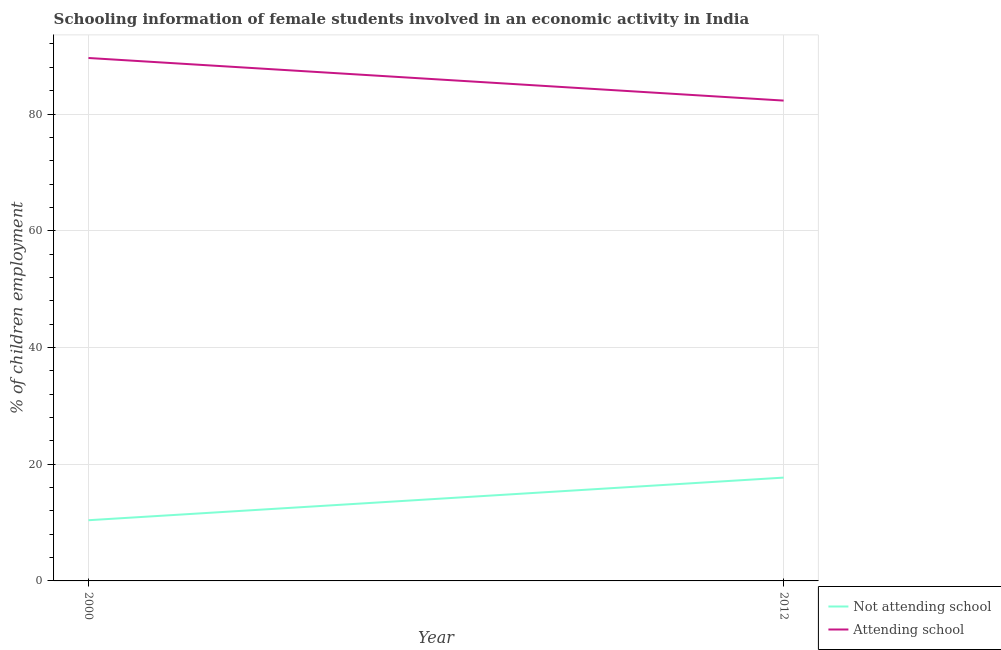What is the percentage of employed females who are not attending school in 2012?
Your answer should be very brief. 17.7. Across all years, what is the maximum percentage of employed females who are not attending school?
Provide a short and direct response. 17.7. In which year was the percentage of employed females who are attending school maximum?
Ensure brevity in your answer.  2000. In which year was the percentage of employed females who are attending school minimum?
Offer a terse response. 2012. What is the total percentage of employed females who are not attending school in the graph?
Offer a terse response. 28.1. What is the difference between the percentage of employed females who are not attending school in 2000 and that in 2012?
Provide a succinct answer. -7.3. What is the difference between the percentage of employed females who are attending school in 2012 and the percentage of employed females who are not attending school in 2000?
Your answer should be compact. 71.9. What is the average percentage of employed females who are attending school per year?
Offer a terse response. 85.95. In the year 2012, what is the difference between the percentage of employed females who are attending school and percentage of employed females who are not attending school?
Make the answer very short. 64.6. In how many years, is the percentage of employed females who are attending school greater than 84 %?
Your answer should be compact. 1. What is the ratio of the percentage of employed females who are attending school in 2000 to that in 2012?
Give a very brief answer. 1.09. In how many years, is the percentage of employed females who are not attending school greater than the average percentage of employed females who are not attending school taken over all years?
Give a very brief answer. 1. Is the percentage of employed females who are attending school strictly greater than the percentage of employed females who are not attending school over the years?
Your answer should be very brief. Yes. How many years are there in the graph?
Provide a short and direct response. 2. What is the difference between two consecutive major ticks on the Y-axis?
Ensure brevity in your answer.  20. Are the values on the major ticks of Y-axis written in scientific E-notation?
Offer a terse response. No. How many legend labels are there?
Give a very brief answer. 2. What is the title of the graph?
Your answer should be compact. Schooling information of female students involved in an economic activity in India. Does "State government" appear as one of the legend labels in the graph?
Ensure brevity in your answer.  No. What is the label or title of the Y-axis?
Make the answer very short. % of children employment. What is the % of children employment of Not attending school in 2000?
Your answer should be very brief. 10.4. What is the % of children employment in Attending school in 2000?
Provide a short and direct response. 89.6. What is the % of children employment of Attending school in 2012?
Provide a short and direct response. 82.3. Across all years, what is the maximum % of children employment in Not attending school?
Your response must be concise. 17.7. Across all years, what is the maximum % of children employment of Attending school?
Your response must be concise. 89.6. Across all years, what is the minimum % of children employment in Attending school?
Provide a short and direct response. 82.3. What is the total % of children employment of Not attending school in the graph?
Provide a short and direct response. 28.1. What is the total % of children employment in Attending school in the graph?
Ensure brevity in your answer.  171.9. What is the difference between the % of children employment in Not attending school in 2000 and the % of children employment in Attending school in 2012?
Ensure brevity in your answer.  -71.9. What is the average % of children employment of Not attending school per year?
Offer a very short reply. 14.05. What is the average % of children employment of Attending school per year?
Ensure brevity in your answer.  85.95. In the year 2000, what is the difference between the % of children employment in Not attending school and % of children employment in Attending school?
Your response must be concise. -79.2. In the year 2012, what is the difference between the % of children employment of Not attending school and % of children employment of Attending school?
Your answer should be compact. -64.6. What is the ratio of the % of children employment of Not attending school in 2000 to that in 2012?
Provide a short and direct response. 0.59. What is the ratio of the % of children employment of Attending school in 2000 to that in 2012?
Ensure brevity in your answer.  1.09. What is the difference between the highest and the lowest % of children employment of Not attending school?
Provide a succinct answer. 7.3. 